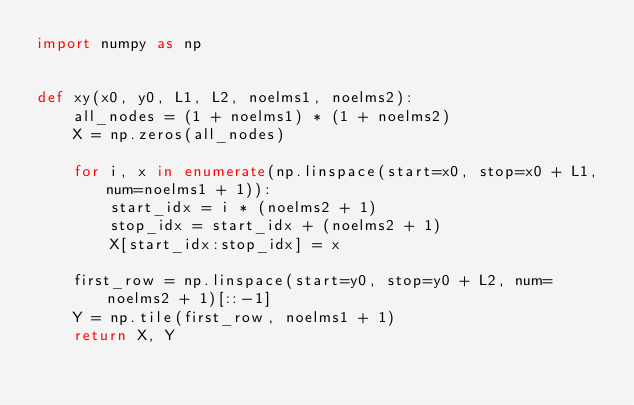<code> <loc_0><loc_0><loc_500><loc_500><_Python_>import numpy as np


def xy(x0, y0, L1, L2, noelms1, noelms2):
    all_nodes = (1 + noelms1) * (1 + noelms2)
    X = np.zeros(all_nodes)

    for i, x in enumerate(np.linspace(start=x0, stop=x0 + L1, num=noelms1 + 1)):
        start_idx = i * (noelms2 + 1)
        stop_idx = start_idx + (noelms2 + 1)
        X[start_idx:stop_idx] = x

    first_row = np.linspace(start=y0, stop=y0 + L2, num=noelms2 + 1)[::-1]
    Y = np.tile(first_row, noelms1 + 1)
    return X, Y
</code> 